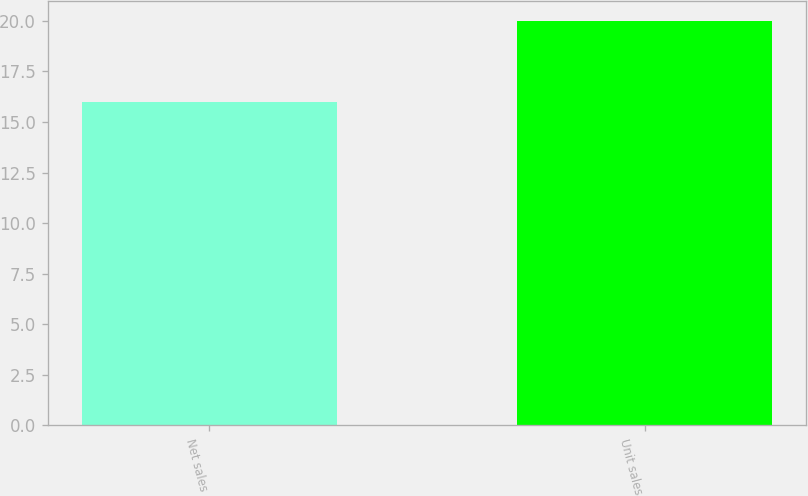Convert chart to OTSL. <chart><loc_0><loc_0><loc_500><loc_500><bar_chart><fcel>Net sales<fcel>Unit sales<nl><fcel>16<fcel>20<nl></chart> 